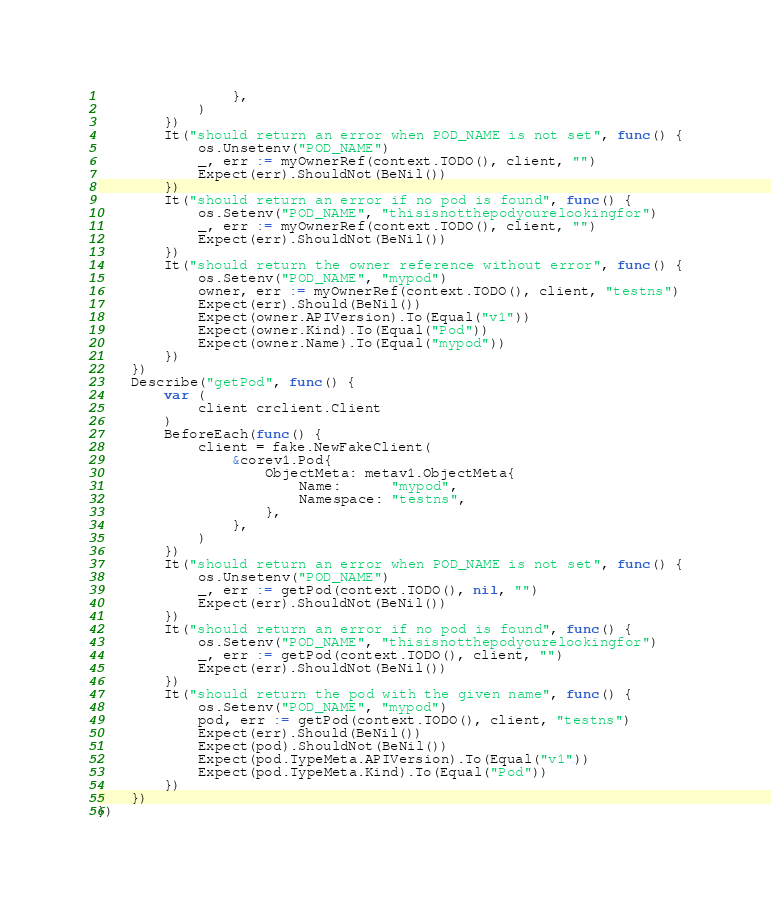<code> <loc_0><loc_0><loc_500><loc_500><_Go_>				},
			)
		})
		It("should return an error when POD_NAME is not set", func() {
			os.Unsetenv("POD_NAME")
			_, err := myOwnerRef(context.TODO(), client, "")
			Expect(err).ShouldNot(BeNil())
		})
		It("should return an error if no pod is found", func() {
			os.Setenv("POD_NAME", "thisisnotthepodyourelookingfor")
			_, err := myOwnerRef(context.TODO(), client, "")
			Expect(err).ShouldNot(BeNil())
		})
		It("should return the owner reference without error", func() {
			os.Setenv("POD_NAME", "mypod")
			owner, err := myOwnerRef(context.TODO(), client, "testns")
			Expect(err).Should(BeNil())
			Expect(owner.APIVersion).To(Equal("v1"))
			Expect(owner.Kind).To(Equal("Pod"))
			Expect(owner.Name).To(Equal("mypod"))
		})
	})
	Describe("getPod", func() {
		var (
			client crclient.Client
		)
		BeforeEach(func() {
			client = fake.NewFakeClient(
				&corev1.Pod{
					ObjectMeta: metav1.ObjectMeta{
						Name:      "mypod",
						Namespace: "testns",
					},
				},
			)
		})
		It("should return an error when POD_NAME is not set", func() {
			os.Unsetenv("POD_NAME")
			_, err := getPod(context.TODO(), nil, "")
			Expect(err).ShouldNot(BeNil())
		})
		It("should return an error if no pod is found", func() {
			os.Setenv("POD_NAME", "thisisnotthepodyourelookingfor")
			_, err := getPod(context.TODO(), client, "")
			Expect(err).ShouldNot(BeNil())
		})
		It("should return the pod with the given name", func() {
			os.Setenv("POD_NAME", "mypod")
			pod, err := getPod(context.TODO(), client, "testns")
			Expect(err).Should(BeNil())
			Expect(pod).ShouldNot(BeNil())
			Expect(pod.TypeMeta.APIVersion).To(Equal("v1"))
			Expect(pod.TypeMeta.Kind).To(Equal("Pod"))
		})
	})
})
</code> 